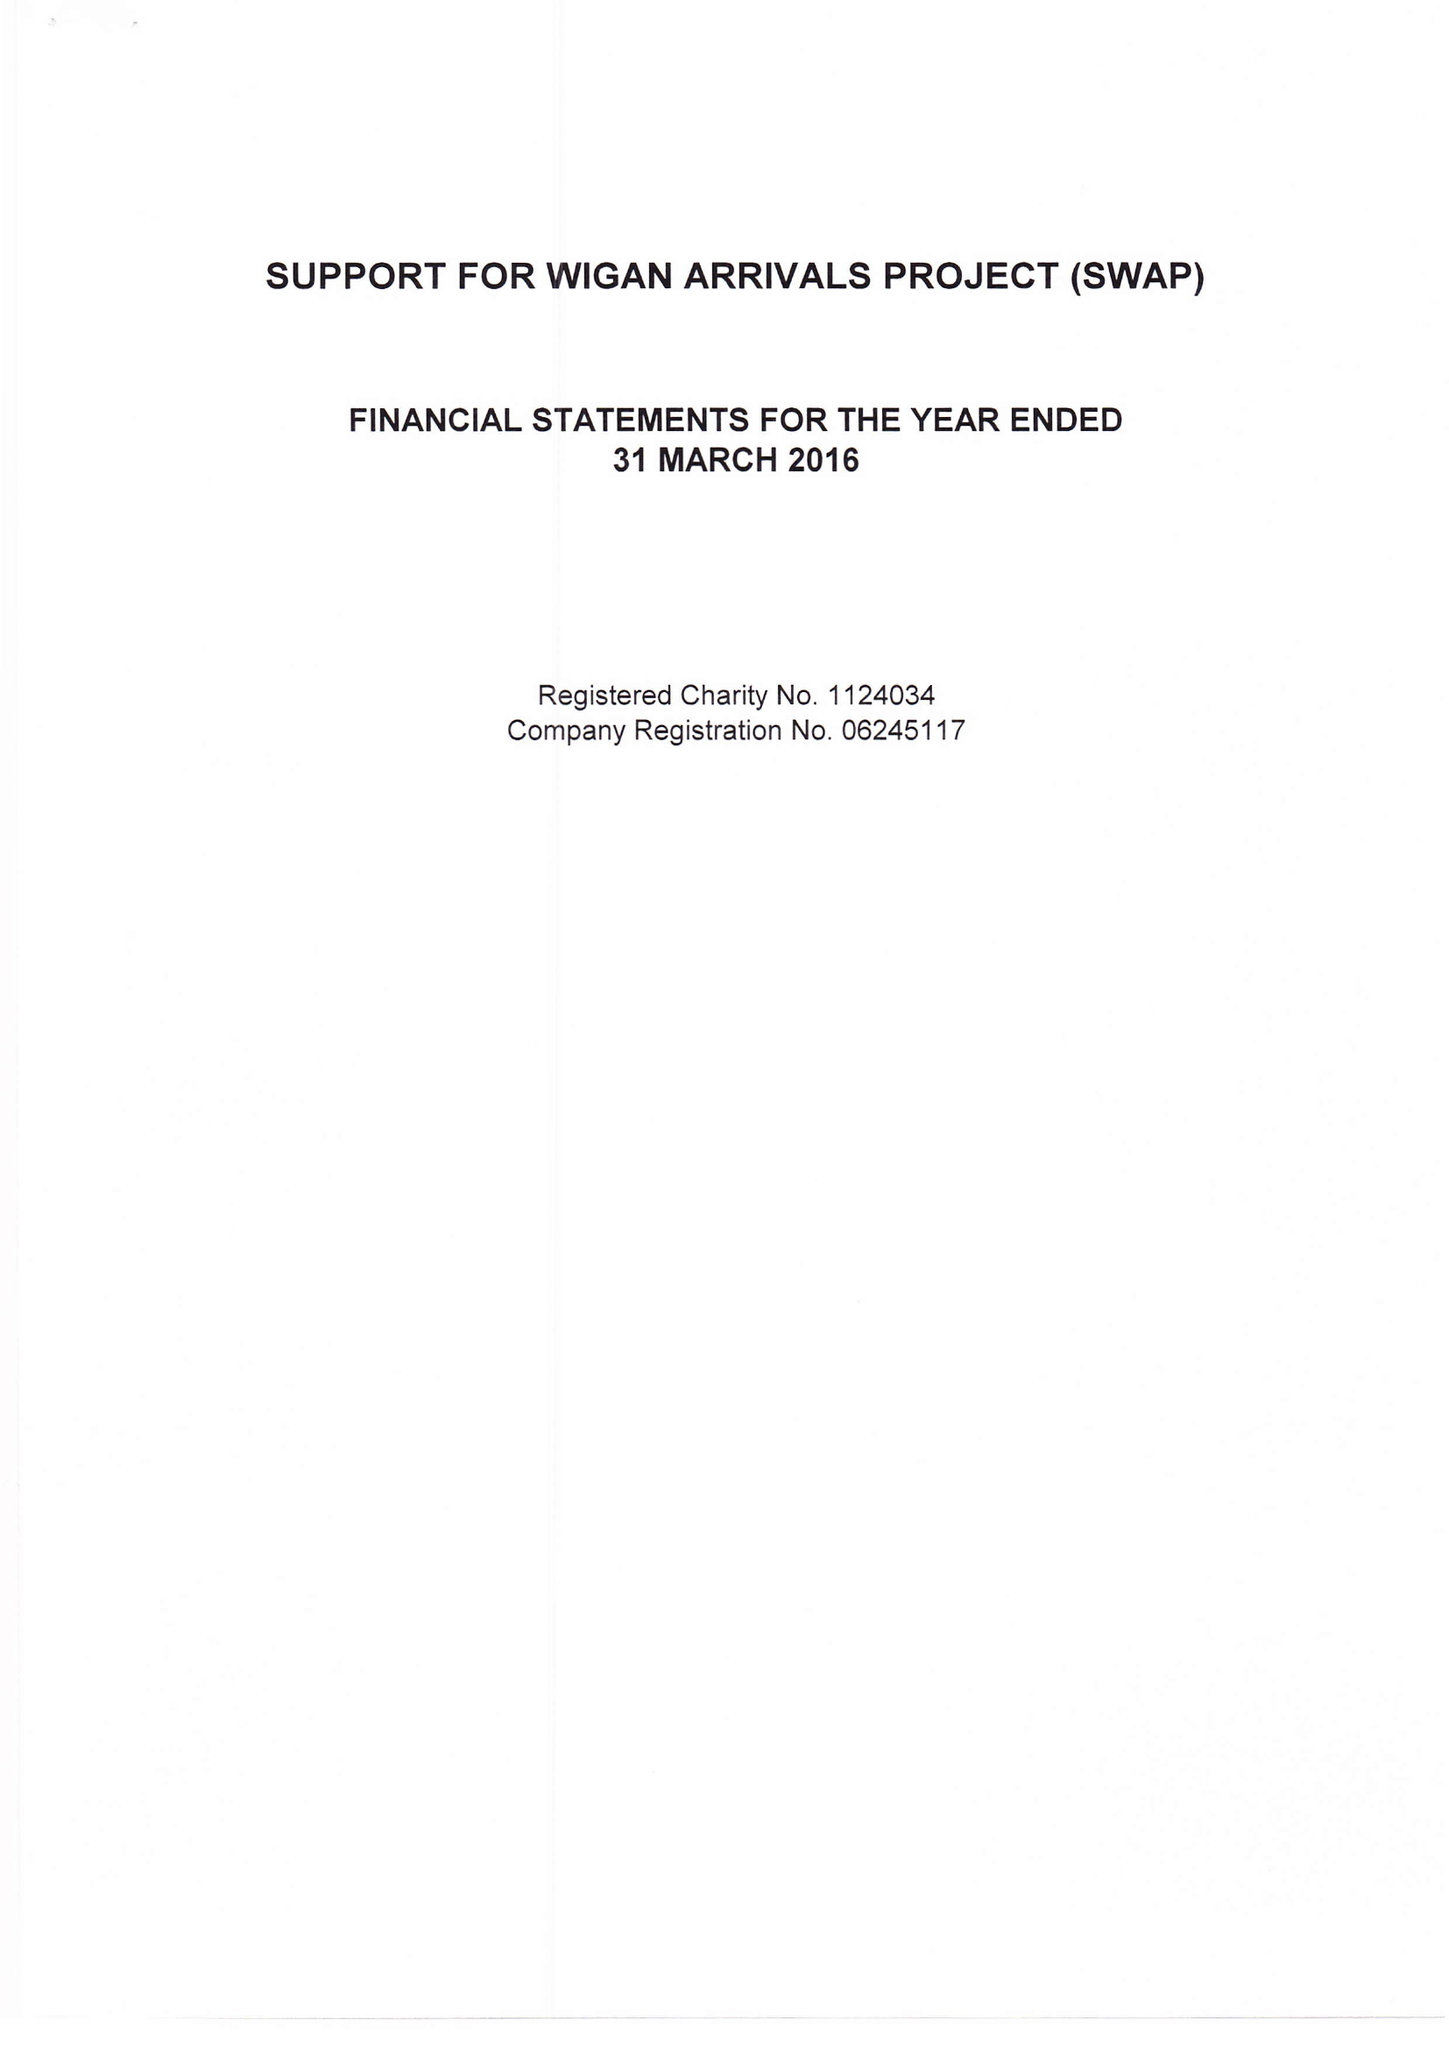What is the value for the address__post_town?
Answer the question using a single word or phrase. WIGAN 